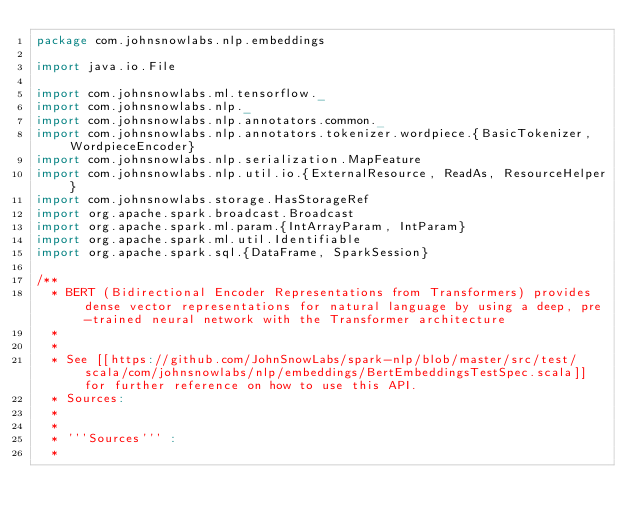Convert code to text. <code><loc_0><loc_0><loc_500><loc_500><_Scala_>package com.johnsnowlabs.nlp.embeddings

import java.io.File

import com.johnsnowlabs.ml.tensorflow._
import com.johnsnowlabs.nlp._
import com.johnsnowlabs.nlp.annotators.common._
import com.johnsnowlabs.nlp.annotators.tokenizer.wordpiece.{BasicTokenizer, WordpieceEncoder}
import com.johnsnowlabs.nlp.serialization.MapFeature
import com.johnsnowlabs.nlp.util.io.{ExternalResource, ReadAs, ResourceHelper}
import com.johnsnowlabs.storage.HasStorageRef
import org.apache.spark.broadcast.Broadcast
import org.apache.spark.ml.param.{IntArrayParam, IntParam}
import org.apache.spark.ml.util.Identifiable
import org.apache.spark.sql.{DataFrame, SparkSession}

/**
  * BERT (Bidirectional Encoder Representations from Transformers) provides dense vector representations for natural language by using a deep, pre-trained neural network with the Transformer architecture
  *
  *
  * See [[https://github.com/JohnSnowLabs/spark-nlp/blob/master/src/test/scala/com/johnsnowlabs/nlp/embeddings/BertEmbeddingsTestSpec.scala]] for further reference on how to use this API.
  * Sources:
  *
  *
  * '''Sources''' :
  *</code> 